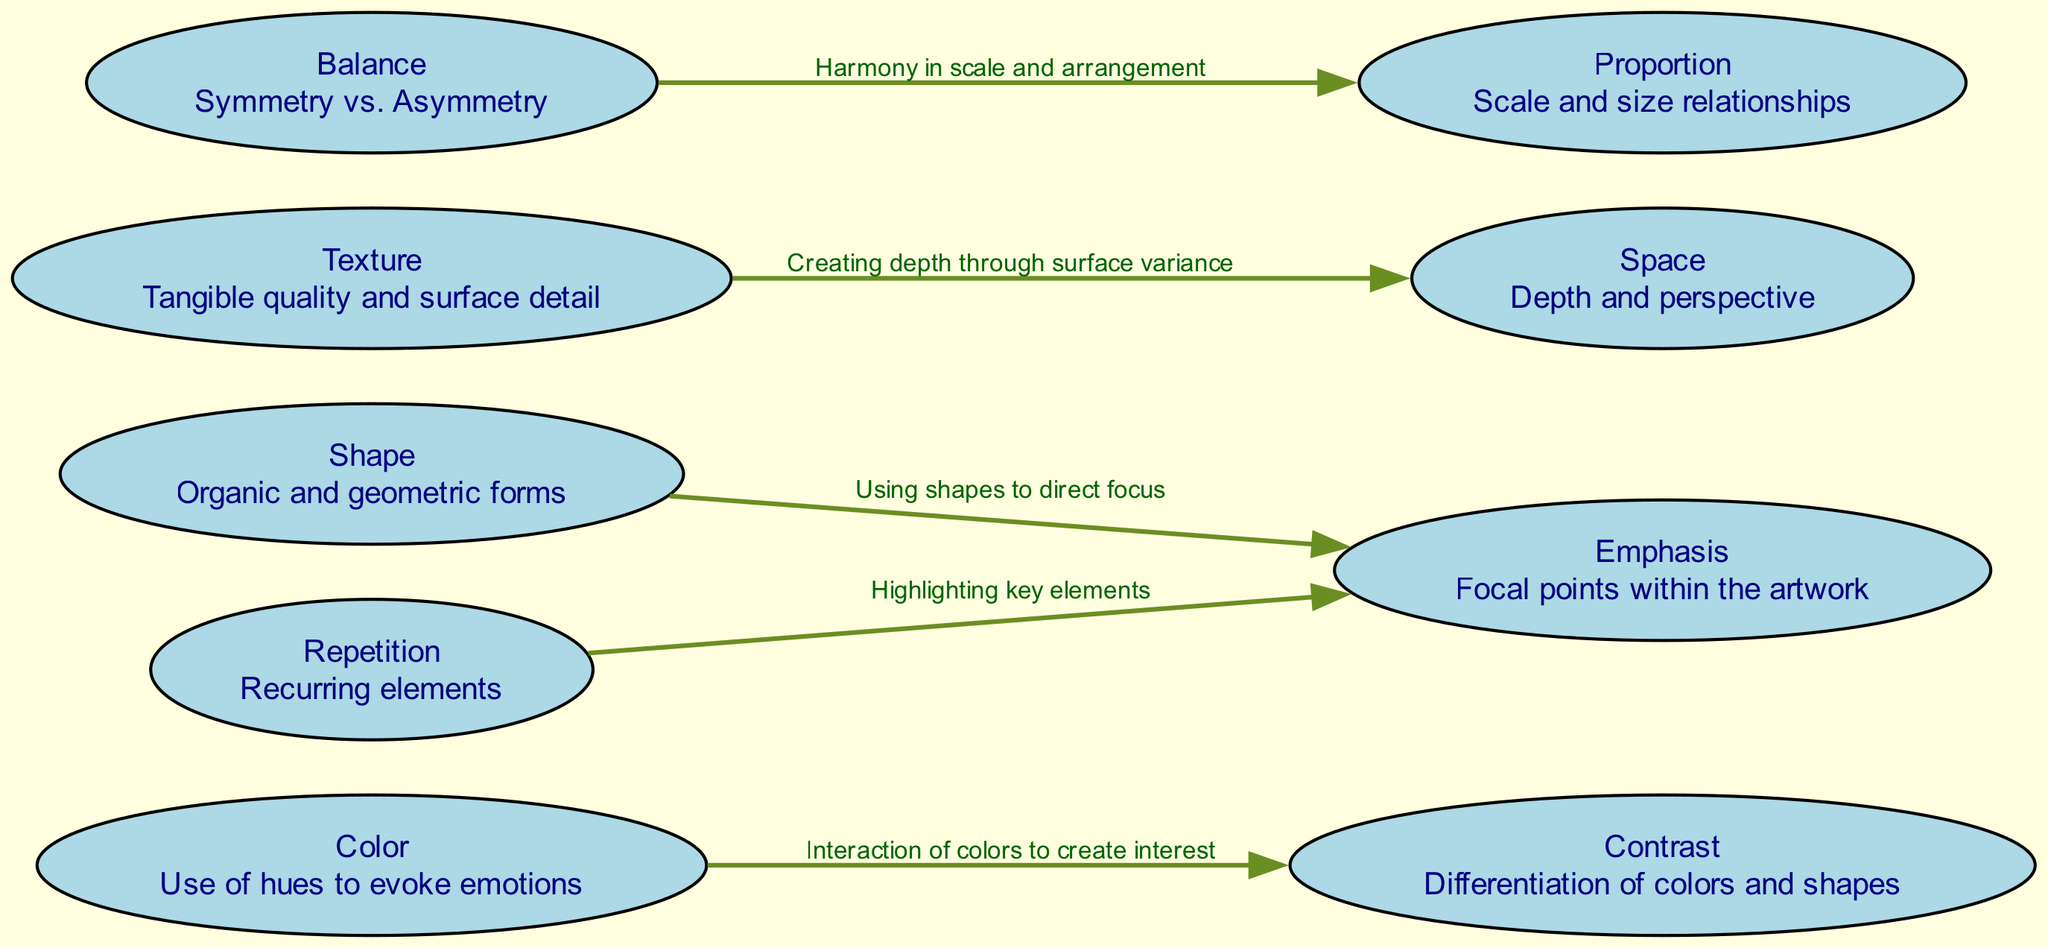What are the elements of design shown in the diagram? The diagram includes nodes labeled with different design elements: color, shape, texture, space, contrast, emphasis, balance, repetition, and proportion. These nodes represent the various components that contribute to surrealistic compositions.
Answer: color, shape, texture, space, contrast, emphasis, balance, repetition, proportion How many edges are there in the diagram? The diagram features connections (or edges) between nodes, which represent relationships. There are a total of five edges connecting various elements of design.
Answer: 5 What is the relationship between color and contrast? The diagram specifies that color interacts with contrast by creating interest. This relationship indicates that how colors are used can emphasize their differences, thus enhancing visual appeal.
Answer: Interaction of colors to create interest Which element is used to direct focus to focal points within the artwork? The diagram shows that the element of shape is used to create emphasis, directing viewers’ attention to certain areas of the art piece.
Answer: Shape What does texture create in the context of space? According to the diagram, texture contributes to space by creating depth through surface variance. This implies that varying the texture in a composition can enhance the illusion of three-dimensional space.
Answer: Depth through surface variance How does balance relate to proportion in design? The diagram illustrates that balance and proportion work together to achieve harmony in scale and arrangement. This means that how elements are balanced correlates with their size relationships to one another.
Answer: Harmony in scale and arrangement Which two elements are interconnected to highlight key elements in art? The diagram indicates that repetition and emphasis are interlinked. Repetition can serve to highlight specific elements of the artwork, drawing attention and reinforcing the central theme.
Answer: Repetition and emphasis What is the role of shape in surrealistic compositions according to the diagram? The diagram states that shapes are significant as they direct focus, playing a crucial role in guiding the viewer's attention to various parts of the artwork.
Answer: Direct focus 